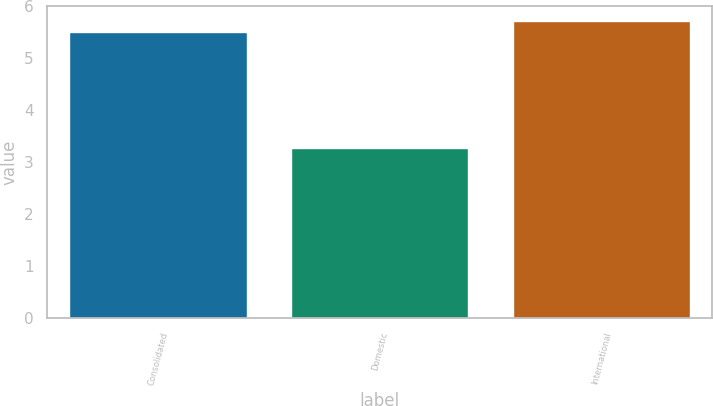<chart> <loc_0><loc_0><loc_500><loc_500><bar_chart><fcel>Consolidated<fcel>Domestic<fcel>International<nl><fcel>5.5<fcel>3.27<fcel>5.72<nl></chart> 